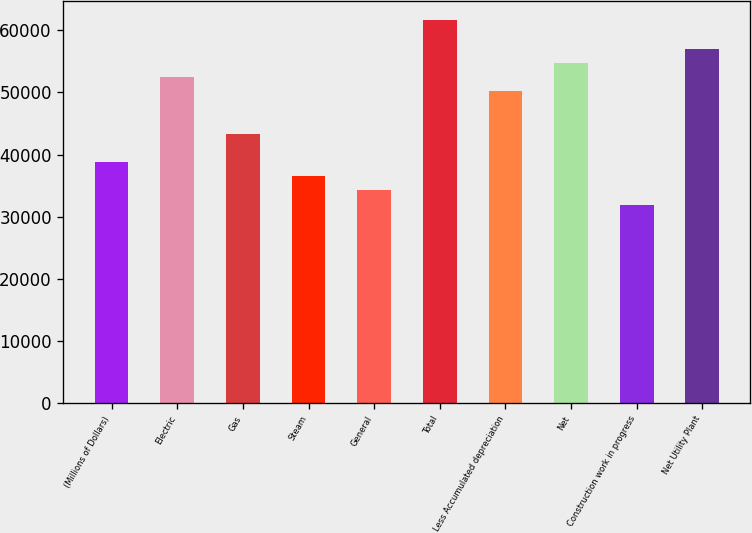Convert chart. <chart><loc_0><loc_0><loc_500><loc_500><bar_chart><fcel>(Millions of Dollars)<fcel>Electric<fcel>Gas<fcel>Steam<fcel>General<fcel>Total<fcel>Less Accumulated depreciation<fcel>Net<fcel>Construction work in progress<fcel>Net Utility Plant<nl><fcel>38784.4<fcel>52471.6<fcel>43346.8<fcel>36503.2<fcel>34222<fcel>61596.4<fcel>50190.4<fcel>54752.8<fcel>31940.8<fcel>57034<nl></chart> 